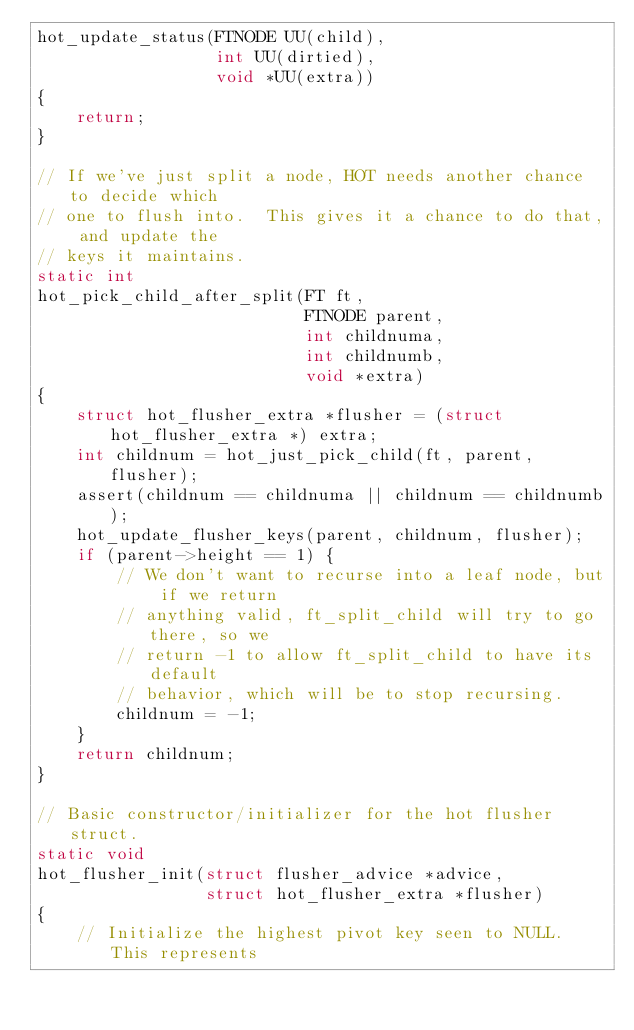Convert code to text. <code><loc_0><loc_0><loc_500><loc_500><_C++_>hot_update_status(FTNODE UU(child),
                  int UU(dirtied),
                  void *UU(extra))
{
    return;
}

// If we've just split a node, HOT needs another chance to decide which
// one to flush into.  This gives it a chance to do that, and update the
// keys it maintains.
static int
hot_pick_child_after_split(FT ft,
                           FTNODE parent,
                           int childnuma,
                           int childnumb,
                           void *extra)
{
    struct hot_flusher_extra *flusher = (struct hot_flusher_extra *) extra;
    int childnum = hot_just_pick_child(ft, parent, flusher);
    assert(childnum == childnuma || childnum == childnumb);
    hot_update_flusher_keys(parent, childnum, flusher);
    if (parent->height == 1) {
        // We don't want to recurse into a leaf node, but if we return
        // anything valid, ft_split_child will try to go there, so we
        // return -1 to allow ft_split_child to have its default
        // behavior, which will be to stop recursing.
        childnum = -1;
    }
    return childnum;
}

// Basic constructor/initializer for the hot flusher struct.
static void
hot_flusher_init(struct flusher_advice *advice,
                 struct hot_flusher_extra *flusher)
{
    // Initialize the highest pivot key seen to NULL.  This represents</code> 